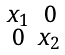Convert formula to latex. <formula><loc_0><loc_0><loc_500><loc_500>\begin{smallmatrix} x _ { 1 } & 0 \\ 0 & x _ { 2 } \end{smallmatrix}</formula> 